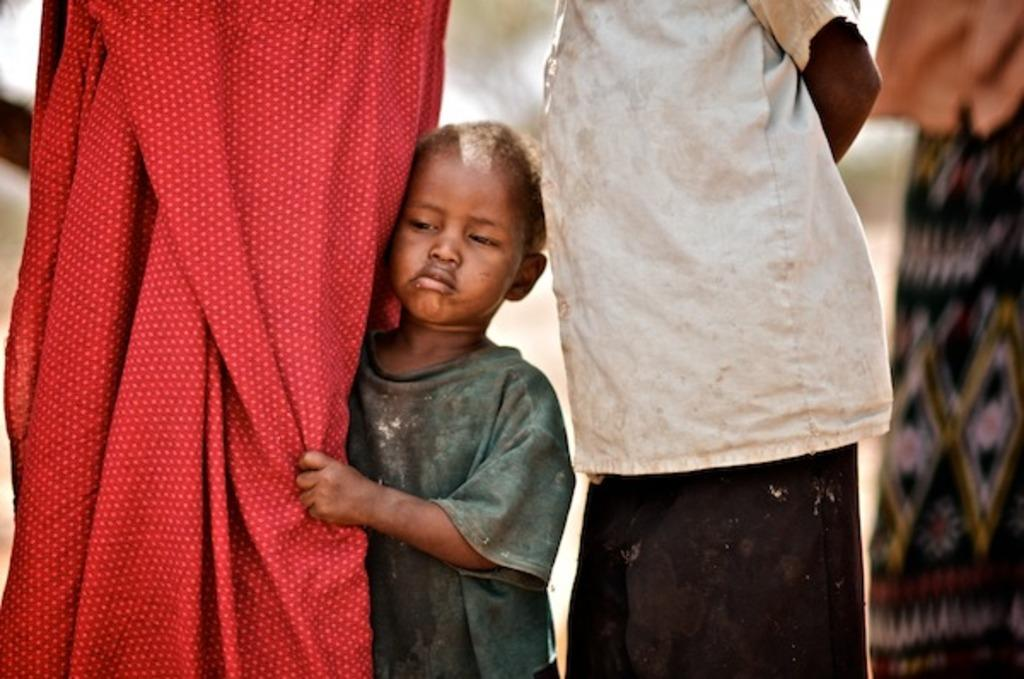What can be observed about the people in the image? There are people standing in the image, and a child is present among them, in the middle. What is the child wearing? The child is wearing a t-shirt. How would you describe the background of the image? The background of the image is blurred. What type of zinc is the manager using to create bubbles in the image? There is no manager, zinc, or bubbles present in the image. 